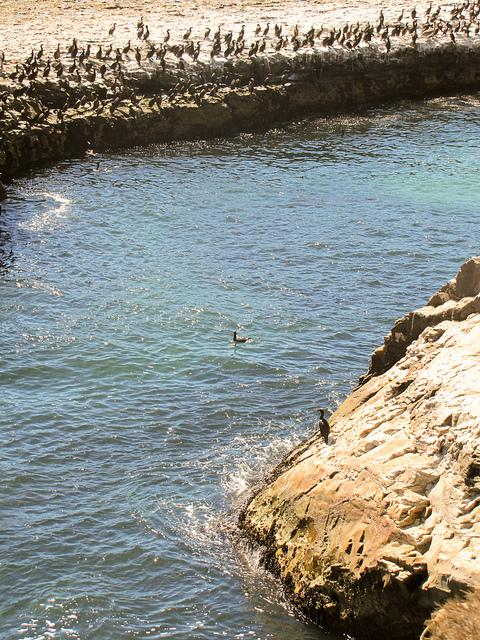What is usually found inside of the large blue item? Please explain your reasoning. fish. There are a bunch of fish in the large river. 